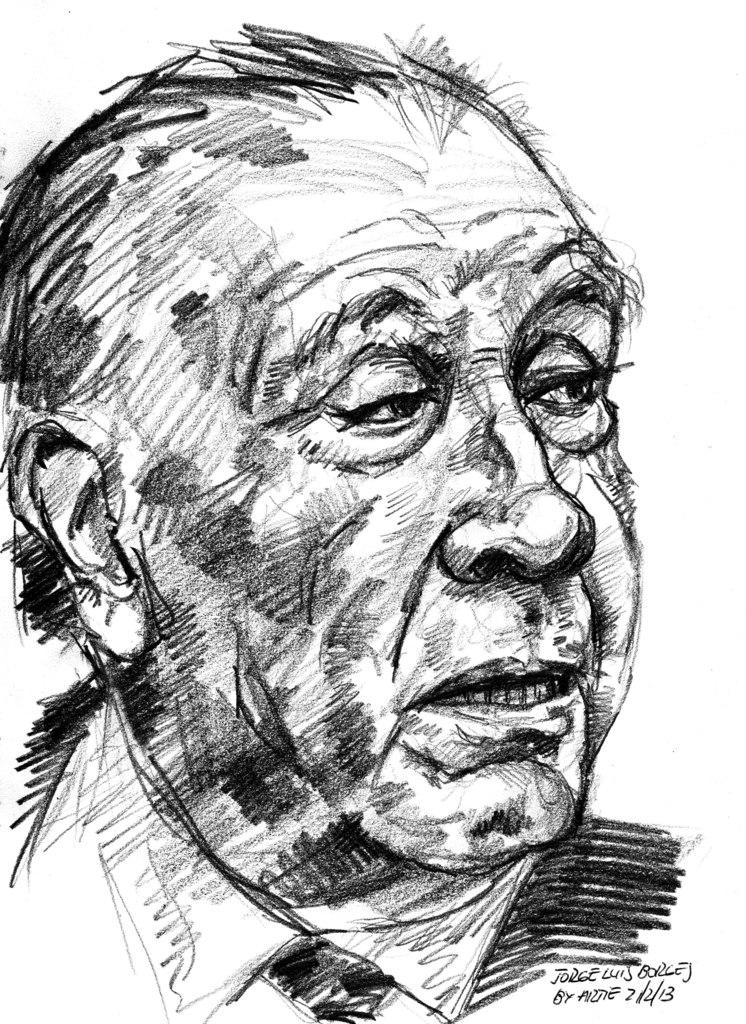What is the main subject of the image? The main subject of the image is a sketch of a man. What else can be seen in the image besides the sketch? There is text in the image. How much money is the man holding in the image? There is no money present in the image; it only features a sketch of a man and text. 